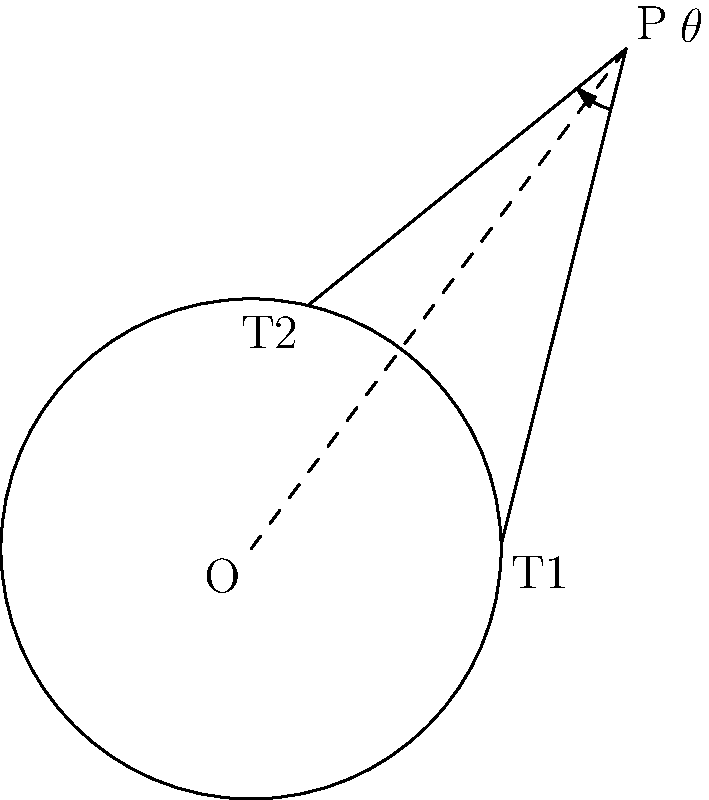In your latest album review, you've cleverly compared the artist's musical progression to a geometric problem. Two tangent lines are drawn from an external point P to a circle with center O. If the angle between these tangent lines is $\theta$, and OP = 5 units while the radius of the circle is 3 units, determine the value of $\tan(\frac{\theta}{2})$. How might this ratio reflect the artist's growth in their musical journey? Let's approach this step-by-step, just as we would analyze an artist's musical evolution:

1) In a circle where tangent lines are drawn from an external point, these tangents are always equal in length. Let's call this length x.

2) The triangle OPT (where T is either tangent point) is right-angled, as the radius is perpendicular to the tangent at the point of contact.

3) In this right-angled triangle:
   $OP^2 = OT^2 + PT^2$
   $5^2 = 3^2 + x^2$
   $25 = 9 + x^2$
   $x^2 = 16$
   $x = 4$

4) Now, in the triangle formed by the two tangent lines and OP:
   $\tan(\frac{\theta}{2}) = \frac{OT}{PT} = \frac{3}{4}$

5) This ratio, 3:4, could symbolize the artist's growth. Perhaps they've maintained 3 parts of their original style while incorporating 4 parts of new influences.
Answer: $\frac{3}{4}$ 